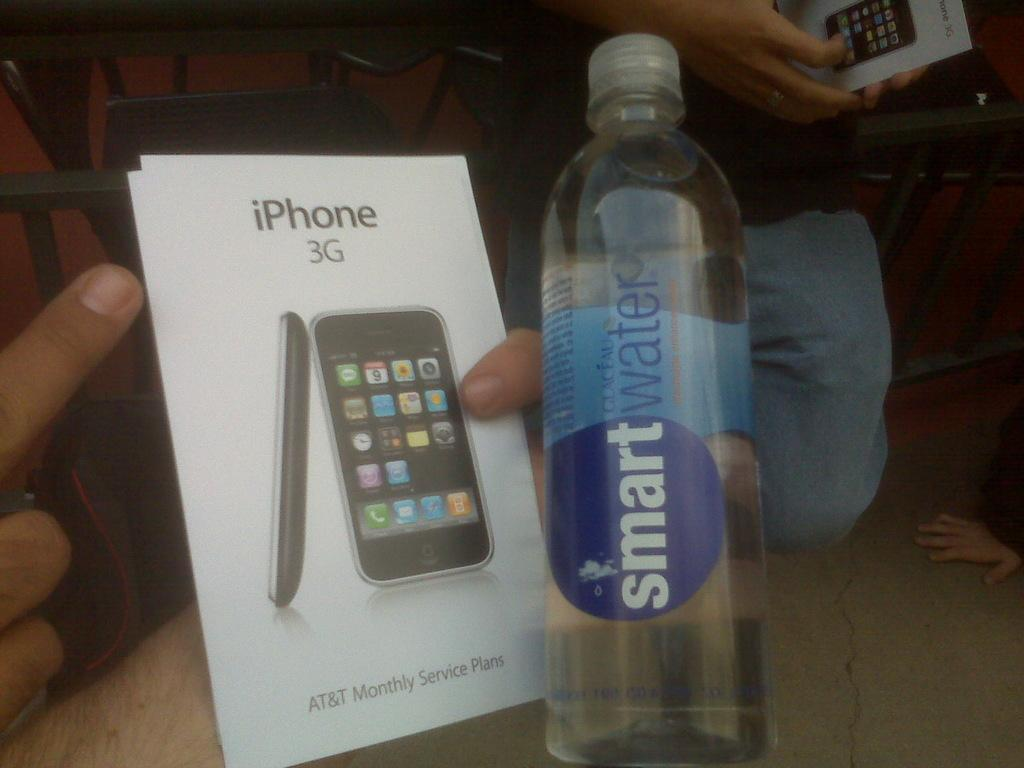<image>
Create a compact narrative representing the image presented. Smart water bottle and a box cover for the new iPhone that comes with 3G. 